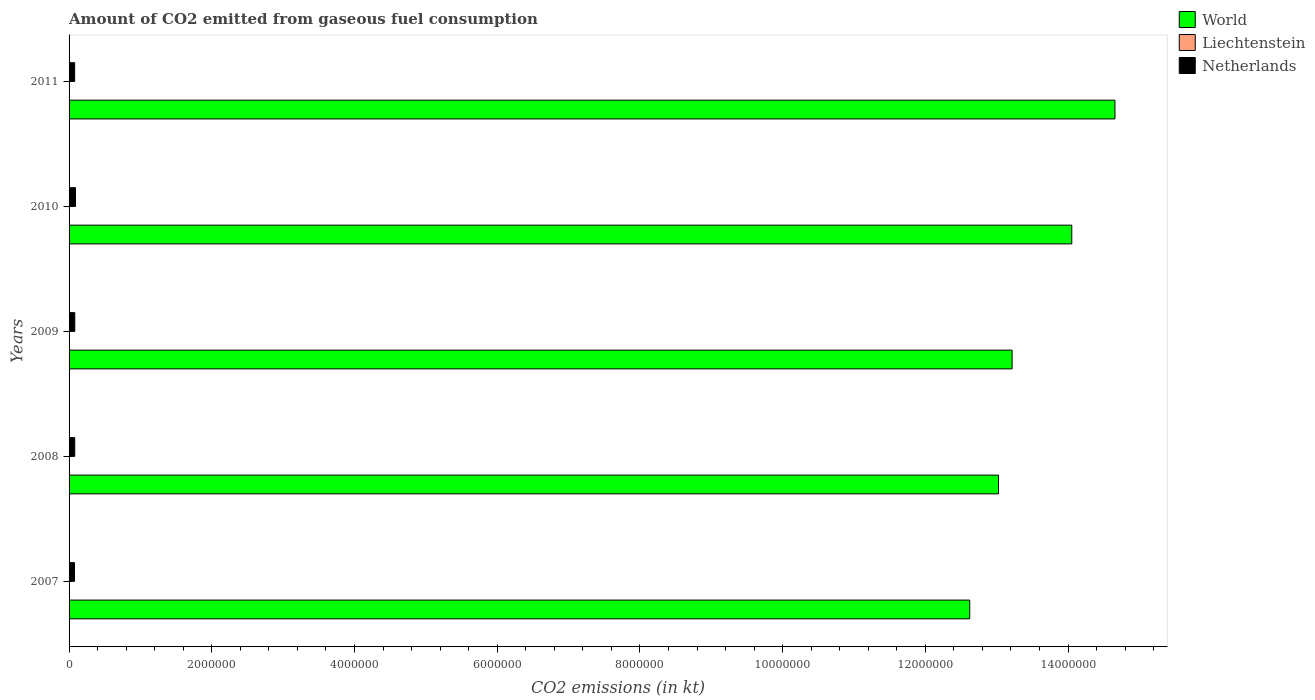Are the number of bars per tick equal to the number of legend labels?
Offer a very short reply. Yes. Are the number of bars on each tick of the Y-axis equal?
Your response must be concise. Yes. How many bars are there on the 3rd tick from the top?
Provide a succinct answer. 3. How many bars are there on the 1st tick from the bottom?
Offer a terse response. 3. What is the amount of CO2 emitted in World in 2007?
Your answer should be compact. 1.26e+07. Across all years, what is the maximum amount of CO2 emitted in Liechtenstein?
Provide a succinct answer. 69.67. Across all years, what is the minimum amount of CO2 emitted in World?
Your answer should be compact. 1.26e+07. In which year was the amount of CO2 emitted in World maximum?
Offer a very short reply. 2011. What is the total amount of CO2 emitted in World in the graph?
Your answer should be compact. 6.76e+07. What is the difference between the amount of CO2 emitted in Liechtenstein in 2007 and that in 2010?
Make the answer very short. 11. What is the difference between the amount of CO2 emitted in World in 2008 and the amount of CO2 emitted in Netherlands in 2007?
Your answer should be compact. 1.29e+07. What is the average amount of CO2 emitted in Liechtenstein per year?
Offer a very short reply. 60.87. In the year 2011, what is the difference between the amount of CO2 emitted in Liechtenstein and amount of CO2 emitted in Netherlands?
Offer a very short reply. -7.83e+04. What is the ratio of the amount of CO2 emitted in Netherlands in 2008 to that in 2010?
Keep it short and to the point. 0.88. Is the amount of CO2 emitted in Liechtenstein in 2007 less than that in 2009?
Offer a terse response. No. What is the difference between the highest and the lowest amount of CO2 emitted in World?
Offer a terse response. 2.04e+06. Is it the case that in every year, the sum of the amount of CO2 emitted in Netherlands and amount of CO2 emitted in Liechtenstein is greater than the amount of CO2 emitted in World?
Offer a terse response. No. How many bars are there?
Provide a succinct answer. 15. Are all the bars in the graph horizontal?
Your response must be concise. Yes. What is the title of the graph?
Provide a short and direct response. Amount of CO2 emitted from gaseous fuel consumption. What is the label or title of the X-axis?
Your response must be concise. CO2 emissions (in kt). What is the label or title of the Y-axis?
Give a very brief answer. Years. What is the CO2 emissions (in kt) of World in 2007?
Offer a terse response. 1.26e+07. What is the CO2 emissions (in kt) of Liechtenstein in 2007?
Provide a short and direct response. 69.67. What is the CO2 emissions (in kt) of Netherlands in 2007?
Offer a very short reply. 7.62e+04. What is the CO2 emissions (in kt) in World in 2008?
Your answer should be compact. 1.30e+07. What is the CO2 emissions (in kt) in Liechtenstein in 2008?
Your response must be concise. 69.67. What is the CO2 emissions (in kt) in Netherlands in 2008?
Make the answer very short. 7.94e+04. What is the CO2 emissions (in kt) of World in 2009?
Ensure brevity in your answer.  1.32e+07. What is the CO2 emissions (in kt) of Liechtenstein in 2009?
Give a very brief answer. 55.01. What is the CO2 emissions (in kt) of Netherlands in 2009?
Ensure brevity in your answer.  8.01e+04. What is the CO2 emissions (in kt) in World in 2010?
Offer a very short reply. 1.41e+07. What is the CO2 emissions (in kt) of Liechtenstein in 2010?
Provide a short and direct response. 58.67. What is the CO2 emissions (in kt) in Netherlands in 2010?
Your answer should be very brief. 8.98e+04. What is the CO2 emissions (in kt) in World in 2011?
Make the answer very short. 1.47e+07. What is the CO2 emissions (in kt) in Liechtenstein in 2011?
Ensure brevity in your answer.  51.34. What is the CO2 emissions (in kt) of Netherlands in 2011?
Give a very brief answer. 7.83e+04. Across all years, what is the maximum CO2 emissions (in kt) in World?
Offer a terse response. 1.47e+07. Across all years, what is the maximum CO2 emissions (in kt) in Liechtenstein?
Provide a succinct answer. 69.67. Across all years, what is the maximum CO2 emissions (in kt) of Netherlands?
Provide a succinct answer. 8.98e+04. Across all years, what is the minimum CO2 emissions (in kt) in World?
Ensure brevity in your answer.  1.26e+07. Across all years, what is the minimum CO2 emissions (in kt) in Liechtenstein?
Make the answer very short. 51.34. Across all years, what is the minimum CO2 emissions (in kt) in Netherlands?
Make the answer very short. 7.62e+04. What is the total CO2 emissions (in kt) in World in the graph?
Give a very brief answer. 6.76e+07. What is the total CO2 emissions (in kt) of Liechtenstein in the graph?
Provide a short and direct response. 304.36. What is the total CO2 emissions (in kt) in Netherlands in the graph?
Offer a terse response. 4.04e+05. What is the difference between the CO2 emissions (in kt) in World in 2007 and that in 2008?
Your response must be concise. -4.03e+05. What is the difference between the CO2 emissions (in kt) of Liechtenstein in 2007 and that in 2008?
Ensure brevity in your answer.  0. What is the difference between the CO2 emissions (in kt) of Netherlands in 2007 and that in 2008?
Provide a succinct answer. -3179.29. What is the difference between the CO2 emissions (in kt) in World in 2007 and that in 2009?
Your answer should be compact. -5.94e+05. What is the difference between the CO2 emissions (in kt) of Liechtenstein in 2007 and that in 2009?
Your response must be concise. 14.67. What is the difference between the CO2 emissions (in kt) of Netherlands in 2007 and that in 2009?
Provide a short and direct response. -3901.69. What is the difference between the CO2 emissions (in kt) of World in 2007 and that in 2010?
Offer a very short reply. -1.43e+06. What is the difference between the CO2 emissions (in kt) in Liechtenstein in 2007 and that in 2010?
Provide a short and direct response. 11. What is the difference between the CO2 emissions (in kt) of Netherlands in 2007 and that in 2010?
Keep it short and to the point. -1.36e+04. What is the difference between the CO2 emissions (in kt) of World in 2007 and that in 2011?
Your response must be concise. -2.04e+06. What is the difference between the CO2 emissions (in kt) in Liechtenstein in 2007 and that in 2011?
Provide a succinct answer. 18.34. What is the difference between the CO2 emissions (in kt) of Netherlands in 2007 and that in 2011?
Provide a short and direct response. -2141.53. What is the difference between the CO2 emissions (in kt) in World in 2008 and that in 2009?
Provide a short and direct response. -1.91e+05. What is the difference between the CO2 emissions (in kt) of Liechtenstein in 2008 and that in 2009?
Ensure brevity in your answer.  14.67. What is the difference between the CO2 emissions (in kt) of Netherlands in 2008 and that in 2009?
Offer a very short reply. -722.4. What is the difference between the CO2 emissions (in kt) in World in 2008 and that in 2010?
Your response must be concise. -1.03e+06. What is the difference between the CO2 emissions (in kt) of Liechtenstein in 2008 and that in 2010?
Offer a very short reply. 11. What is the difference between the CO2 emissions (in kt) of Netherlands in 2008 and that in 2010?
Make the answer very short. -1.04e+04. What is the difference between the CO2 emissions (in kt) in World in 2008 and that in 2011?
Make the answer very short. -1.63e+06. What is the difference between the CO2 emissions (in kt) in Liechtenstein in 2008 and that in 2011?
Make the answer very short. 18.34. What is the difference between the CO2 emissions (in kt) in Netherlands in 2008 and that in 2011?
Provide a short and direct response. 1037.76. What is the difference between the CO2 emissions (in kt) in World in 2009 and that in 2010?
Your answer should be compact. -8.36e+05. What is the difference between the CO2 emissions (in kt) of Liechtenstein in 2009 and that in 2010?
Your answer should be compact. -3.67. What is the difference between the CO2 emissions (in kt) in Netherlands in 2009 and that in 2010?
Offer a terse response. -9699.22. What is the difference between the CO2 emissions (in kt) in World in 2009 and that in 2011?
Your answer should be very brief. -1.44e+06. What is the difference between the CO2 emissions (in kt) in Liechtenstein in 2009 and that in 2011?
Give a very brief answer. 3.67. What is the difference between the CO2 emissions (in kt) of Netherlands in 2009 and that in 2011?
Make the answer very short. 1760.16. What is the difference between the CO2 emissions (in kt) in World in 2010 and that in 2011?
Make the answer very short. -6.05e+05. What is the difference between the CO2 emissions (in kt) in Liechtenstein in 2010 and that in 2011?
Make the answer very short. 7.33. What is the difference between the CO2 emissions (in kt) in Netherlands in 2010 and that in 2011?
Your answer should be compact. 1.15e+04. What is the difference between the CO2 emissions (in kt) in World in 2007 and the CO2 emissions (in kt) in Liechtenstein in 2008?
Your response must be concise. 1.26e+07. What is the difference between the CO2 emissions (in kt) in World in 2007 and the CO2 emissions (in kt) in Netherlands in 2008?
Provide a short and direct response. 1.25e+07. What is the difference between the CO2 emissions (in kt) of Liechtenstein in 2007 and the CO2 emissions (in kt) of Netherlands in 2008?
Your response must be concise. -7.93e+04. What is the difference between the CO2 emissions (in kt) of World in 2007 and the CO2 emissions (in kt) of Liechtenstein in 2009?
Provide a succinct answer. 1.26e+07. What is the difference between the CO2 emissions (in kt) in World in 2007 and the CO2 emissions (in kt) in Netherlands in 2009?
Offer a terse response. 1.25e+07. What is the difference between the CO2 emissions (in kt) of Liechtenstein in 2007 and the CO2 emissions (in kt) of Netherlands in 2009?
Offer a very short reply. -8.00e+04. What is the difference between the CO2 emissions (in kt) in World in 2007 and the CO2 emissions (in kt) in Liechtenstein in 2010?
Ensure brevity in your answer.  1.26e+07. What is the difference between the CO2 emissions (in kt) in World in 2007 and the CO2 emissions (in kt) in Netherlands in 2010?
Provide a short and direct response. 1.25e+07. What is the difference between the CO2 emissions (in kt) of Liechtenstein in 2007 and the CO2 emissions (in kt) of Netherlands in 2010?
Offer a very short reply. -8.97e+04. What is the difference between the CO2 emissions (in kt) in World in 2007 and the CO2 emissions (in kt) in Liechtenstein in 2011?
Provide a succinct answer. 1.26e+07. What is the difference between the CO2 emissions (in kt) in World in 2007 and the CO2 emissions (in kt) in Netherlands in 2011?
Your response must be concise. 1.25e+07. What is the difference between the CO2 emissions (in kt) of Liechtenstein in 2007 and the CO2 emissions (in kt) of Netherlands in 2011?
Keep it short and to the point. -7.83e+04. What is the difference between the CO2 emissions (in kt) in World in 2008 and the CO2 emissions (in kt) in Liechtenstein in 2009?
Keep it short and to the point. 1.30e+07. What is the difference between the CO2 emissions (in kt) of World in 2008 and the CO2 emissions (in kt) of Netherlands in 2009?
Ensure brevity in your answer.  1.29e+07. What is the difference between the CO2 emissions (in kt) of Liechtenstein in 2008 and the CO2 emissions (in kt) of Netherlands in 2009?
Keep it short and to the point. -8.00e+04. What is the difference between the CO2 emissions (in kt) in World in 2008 and the CO2 emissions (in kt) in Liechtenstein in 2010?
Provide a short and direct response. 1.30e+07. What is the difference between the CO2 emissions (in kt) of World in 2008 and the CO2 emissions (in kt) of Netherlands in 2010?
Your response must be concise. 1.29e+07. What is the difference between the CO2 emissions (in kt) in Liechtenstein in 2008 and the CO2 emissions (in kt) in Netherlands in 2010?
Provide a succinct answer. -8.97e+04. What is the difference between the CO2 emissions (in kt) in World in 2008 and the CO2 emissions (in kt) in Liechtenstein in 2011?
Your answer should be very brief. 1.30e+07. What is the difference between the CO2 emissions (in kt) in World in 2008 and the CO2 emissions (in kt) in Netherlands in 2011?
Provide a succinct answer. 1.29e+07. What is the difference between the CO2 emissions (in kt) in Liechtenstein in 2008 and the CO2 emissions (in kt) in Netherlands in 2011?
Keep it short and to the point. -7.83e+04. What is the difference between the CO2 emissions (in kt) in World in 2009 and the CO2 emissions (in kt) in Liechtenstein in 2010?
Your response must be concise. 1.32e+07. What is the difference between the CO2 emissions (in kt) in World in 2009 and the CO2 emissions (in kt) in Netherlands in 2010?
Offer a terse response. 1.31e+07. What is the difference between the CO2 emissions (in kt) of Liechtenstein in 2009 and the CO2 emissions (in kt) of Netherlands in 2010?
Make the answer very short. -8.97e+04. What is the difference between the CO2 emissions (in kt) of World in 2009 and the CO2 emissions (in kt) of Liechtenstein in 2011?
Provide a short and direct response. 1.32e+07. What is the difference between the CO2 emissions (in kt) of World in 2009 and the CO2 emissions (in kt) of Netherlands in 2011?
Keep it short and to the point. 1.31e+07. What is the difference between the CO2 emissions (in kt) of Liechtenstein in 2009 and the CO2 emissions (in kt) of Netherlands in 2011?
Your answer should be very brief. -7.83e+04. What is the difference between the CO2 emissions (in kt) of World in 2010 and the CO2 emissions (in kt) of Liechtenstein in 2011?
Ensure brevity in your answer.  1.41e+07. What is the difference between the CO2 emissions (in kt) of World in 2010 and the CO2 emissions (in kt) of Netherlands in 2011?
Give a very brief answer. 1.40e+07. What is the difference between the CO2 emissions (in kt) of Liechtenstein in 2010 and the CO2 emissions (in kt) of Netherlands in 2011?
Offer a terse response. -7.83e+04. What is the average CO2 emissions (in kt) of World per year?
Keep it short and to the point. 1.35e+07. What is the average CO2 emissions (in kt) in Liechtenstein per year?
Your answer should be compact. 60.87. What is the average CO2 emissions (in kt) in Netherlands per year?
Your answer should be compact. 8.08e+04. In the year 2007, what is the difference between the CO2 emissions (in kt) in World and CO2 emissions (in kt) in Liechtenstein?
Make the answer very short. 1.26e+07. In the year 2007, what is the difference between the CO2 emissions (in kt) of World and CO2 emissions (in kt) of Netherlands?
Provide a succinct answer. 1.25e+07. In the year 2007, what is the difference between the CO2 emissions (in kt) in Liechtenstein and CO2 emissions (in kt) in Netherlands?
Offer a terse response. -7.61e+04. In the year 2008, what is the difference between the CO2 emissions (in kt) of World and CO2 emissions (in kt) of Liechtenstein?
Your response must be concise. 1.30e+07. In the year 2008, what is the difference between the CO2 emissions (in kt) of World and CO2 emissions (in kt) of Netherlands?
Your answer should be very brief. 1.29e+07. In the year 2008, what is the difference between the CO2 emissions (in kt) in Liechtenstein and CO2 emissions (in kt) in Netherlands?
Your response must be concise. -7.93e+04. In the year 2009, what is the difference between the CO2 emissions (in kt) in World and CO2 emissions (in kt) in Liechtenstein?
Provide a short and direct response. 1.32e+07. In the year 2009, what is the difference between the CO2 emissions (in kt) in World and CO2 emissions (in kt) in Netherlands?
Your answer should be compact. 1.31e+07. In the year 2009, what is the difference between the CO2 emissions (in kt) in Liechtenstein and CO2 emissions (in kt) in Netherlands?
Offer a very short reply. -8.00e+04. In the year 2010, what is the difference between the CO2 emissions (in kt) in World and CO2 emissions (in kt) in Liechtenstein?
Your answer should be compact. 1.41e+07. In the year 2010, what is the difference between the CO2 emissions (in kt) in World and CO2 emissions (in kt) in Netherlands?
Give a very brief answer. 1.40e+07. In the year 2010, what is the difference between the CO2 emissions (in kt) in Liechtenstein and CO2 emissions (in kt) in Netherlands?
Ensure brevity in your answer.  -8.97e+04. In the year 2011, what is the difference between the CO2 emissions (in kt) of World and CO2 emissions (in kt) of Liechtenstein?
Offer a very short reply. 1.47e+07. In the year 2011, what is the difference between the CO2 emissions (in kt) in World and CO2 emissions (in kt) in Netherlands?
Your answer should be compact. 1.46e+07. In the year 2011, what is the difference between the CO2 emissions (in kt) of Liechtenstein and CO2 emissions (in kt) of Netherlands?
Offer a terse response. -7.83e+04. What is the ratio of the CO2 emissions (in kt) of World in 2007 to that in 2008?
Your answer should be very brief. 0.97. What is the ratio of the CO2 emissions (in kt) in Netherlands in 2007 to that in 2008?
Give a very brief answer. 0.96. What is the ratio of the CO2 emissions (in kt) in World in 2007 to that in 2009?
Keep it short and to the point. 0.95. What is the ratio of the CO2 emissions (in kt) of Liechtenstein in 2007 to that in 2009?
Give a very brief answer. 1.27. What is the ratio of the CO2 emissions (in kt) of Netherlands in 2007 to that in 2009?
Provide a short and direct response. 0.95. What is the ratio of the CO2 emissions (in kt) in World in 2007 to that in 2010?
Give a very brief answer. 0.9. What is the ratio of the CO2 emissions (in kt) of Liechtenstein in 2007 to that in 2010?
Give a very brief answer. 1.19. What is the ratio of the CO2 emissions (in kt) of Netherlands in 2007 to that in 2010?
Provide a short and direct response. 0.85. What is the ratio of the CO2 emissions (in kt) of World in 2007 to that in 2011?
Provide a short and direct response. 0.86. What is the ratio of the CO2 emissions (in kt) of Liechtenstein in 2007 to that in 2011?
Offer a terse response. 1.36. What is the ratio of the CO2 emissions (in kt) in Netherlands in 2007 to that in 2011?
Ensure brevity in your answer.  0.97. What is the ratio of the CO2 emissions (in kt) in World in 2008 to that in 2009?
Keep it short and to the point. 0.99. What is the ratio of the CO2 emissions (in kt) of Liechtenstein in 2008 to that in 2009?
Make the answer very short. 1.27. What is the ratio of the CO2 emissions (in kt) in World in 2008 to that in 2010?
Keep it short and to the point. 0.93. What is the ratio of the CO2 emissions (in kt) in Liechtenstein in 2008 to that in 2010?
Offer a very short reply. 1.19. What is the ratio of the CO2 emissions (in kt) of Netherlands in 2008 to that in 2010?
Offer a very short reply. 0.88. What is the ratio of the CO2 emissions (in kt) of World in 2008 to that in 2011?
Provide a short and direct response. 0.89. What is the ratio of the CO2 emissions (in kt) in Liechtenstein in 2008 to that in 2011?
Your answer should be very brief. 1.36. What is the ratio of the CO2 emissions (in kt) of Netherlands in 2008 to that in 2011?
Offer a terse response. 1.01. What is the ratio of the CO2 emissions (in kt) in World in 2009 to that in 2010?
Your answer should be compact. 0.94. What is the ratio of the CO2 emissions (in kt) of Liechtenstein in 2009 to that in 2010?
Give a very brief answer. 0.94. What is the ratio of the CO2 emissions (in kt) in Netherlands in 2009 to that in 2010?
Offer a very short reply. 0.89. What is the ratio of the CO2 emissions (in kt) of World in 2009 to that in 2011?
Make the answer very short. 0.9. What is the ratio of the CO2 emissions (in kt) in Liechtenstein in 2009 to that in 2011?
Make the answer very short. 1.07. What is the ratio of the CO2 emissions (in kt) of Netherlands in 2009 to that in 2011?
Ensure brevity in your answer.  1.02. What is the ratio of the CO2 emissions (in kt) of World in 2010 to that in 2011?
Keep it short and to the point. 0.96. What is the ratio of the CO2 emissions (in kt) of Liechtenstein in 2010 to that in 2011?
Provide a succinct answer. 1.14. What is the ratio of the CO2 emissions (in kt) of Netherlands in 2010 to that in 2011?
Provide a succinct answer. 1.15. What is the difference between the highest and the second highest CO2 emissions (in kt) in World?
Offer a very short reply. 6.05e+05. What is the difference between the highest and the second highest CO2 emissions (in kt) of Liechtenstein?
Make the answer very short. 0. What is the difference between the highest and the second highest CO2 emissions (in kt) of Netherlands?
Your response must be concise. 9699.22. What is the difference between the highest and the lowest CO2 emissions (in kt) in World?
Give a very brief answer. 2.04e+06. What is the difference between the highest and the lowest CO2 emissions (in kt) of Liechtenstein?
Make the answer very short. 18.34. What is the difference between the highest and the lowest CO2 emissions (in kt) of Netherlands?
Provide a short and direct response. 1.36e+04. 